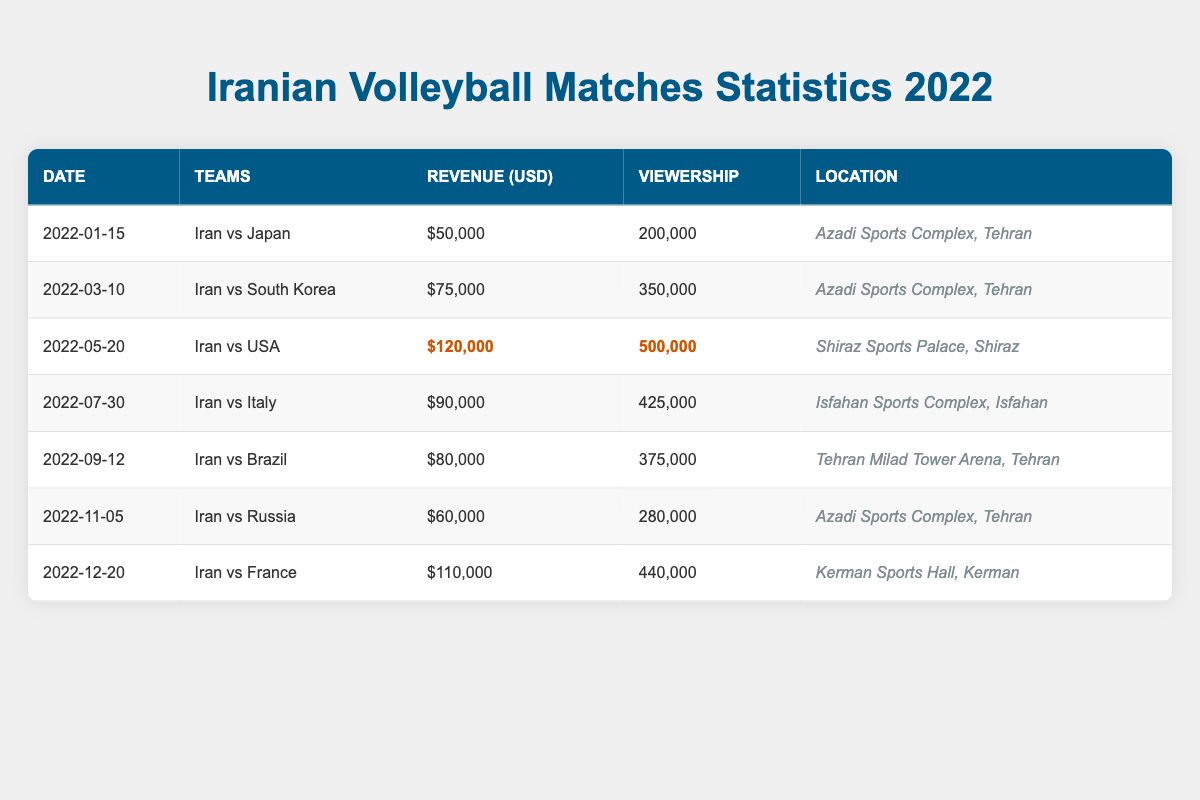What was the revenue for the match between Iran and the USA on May 20, 2022? The table shows that the revenue for the match on May 20, 2022, between Iran and the USA is listed under the "Revenue (USD)" column as $120,000.
Answer: $120,000 Which match had the highest viewership in 2022? By examining the "Viewership" column, the highest value is 500,000, which corresponds to the match against the USA on May 20, 2022.
Answer: The match against the USA What was the total revenue generated from matches against South Korea and Brazil? The revenue for the South Korea match is $75,000 and for the Brazil match is $80,000. Adding these together gives $75,000 + $80,000 = $155,000.
Answer: $155,000 Did Iran play a match at the Tehran Milad Tower Arena in 2022? Yes, there was a match on September 12, 2022, between Iran and Brazil at the Tehran Milad Tower Arena, as indicated in the "Location" column.
Answer: Yes What was the average viewership across all matches? To find the average viewership, first add all the viewership numbers: 200,000 + 350,000 + 500,000 + 425,000 + 375,000 + 280,000 + 440,000 = 2,570,000. Then divide this sum by the number of matches (7): 2,570,000 ÷ 7 ≈ 367,143.
Answer: Approximately 367,143 Which match had the lowest revenue, and what was that value? The lowest revenue is $50,000 for the match against Japan on January 15, 2022, according to the "Revenue (USD)" column.
Answer: $50,000 What was the difference in revenue between the matches against Italy and France? The revenue for the match against Italy is $90,000 and for France is $110,000. The difference is $110,000 - $90,000 = $20,000.
Answer: $20,000 How many matches had viewership of over 400,000? By counting the viewership figures that are greater than 400,000, we find there are four matches: against USA (500,000), Italy (425,000), and France (440,000).
Answer: 4 matches Which venue hosted the match with the second-highest viewership? The match with the second-highest viewership is against Italy, which had 425,000 viewers and took place at the Isfahan Sports Complex.
Answer: Isfahan Sports Complex Was the match against Japan the only match held in January? Yes, according to the "Date" column, the only match listed for January is against Japan on January 15, 2022.
Answer: Yes What was the total revenue for matches held in Tehran? The matches held in Tehran were against Japan ($50,000), South Korea ($75,000), and Russia ($60,000). Adding these gives $50,000 + $75,000 + $60,000 = $185,000.
Answer: $185,000 